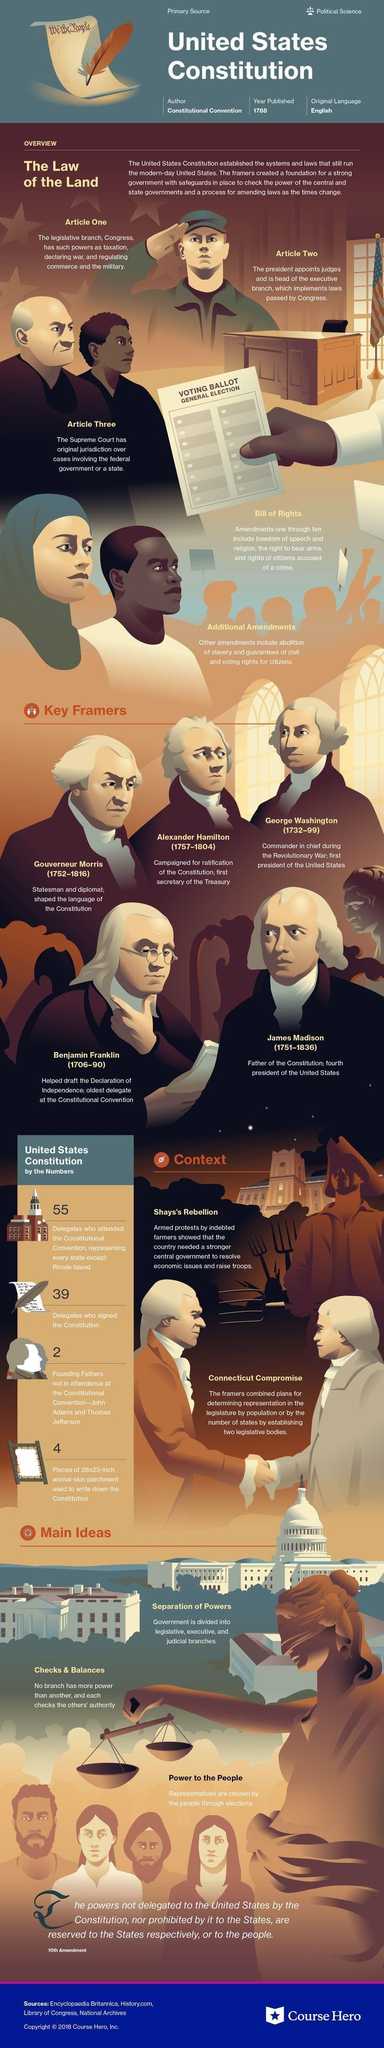How many articles are mentioned?
Answer the question with a short phrase. Three Which president is Father of Constitution? James Madison How many amendments are mentioned under Bill of Rights? ten Who regulates military? The legislative branch What was the size of material used to write the Constitution? 28x23-inch 